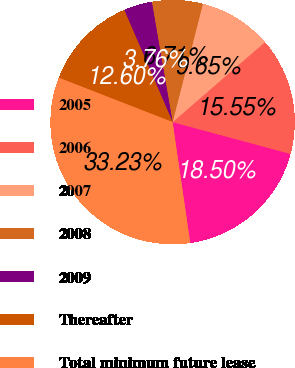Convert chart to OTSL. <chart><loc_0><loc_0><loc_500><loc_500><pie_chart><fcel>2005<fcel>2006<fcel>2007<fcel>2008<fcel>2009<fcel>Thereafter<fcel>Total minimum future lease<nl><fcel>18.5%<fcel>15.55%<fcel>9.65%<fcel>6.71%<fcel>3.76%<fcel>12.6%<fcel>33.23%<nl></chart> 